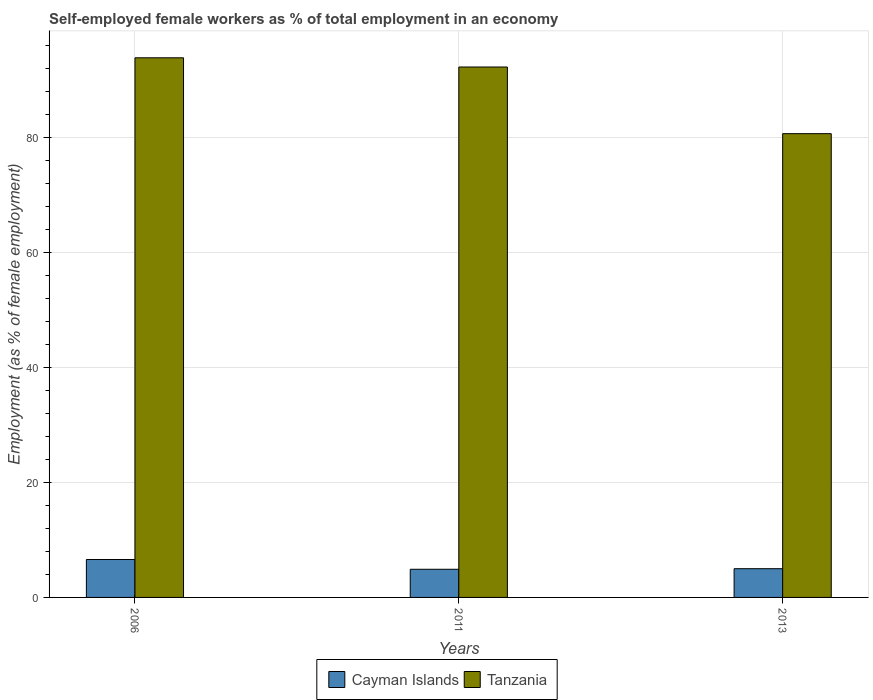How many groups of bars are there?
Offer a very short reply. 3. Are the number of bars per tick equal to the number of legend labels?
Your answer should be compact. Yes. Are the number of bars on each tick of the X-axis equal?
Your answer should be compact. Yes. How many bars are there on the 2nd tick from the right?
Keep it short and to the point. 2. What is the percentage of self-employed female workers in Tanzania in 2011?
Offer a terse response. 92.3. Across all years, what is the maximum percentage of self-employed female workers in Tanzania?
Your answer should be very brief. 93.9. Across all years, what is the minimum percentage of self-employed female workers in Tanzania?
Your answer should be very brief. 80.7. What is the total percentage of self-employed female workers in Cayman Islands in the graph?
Your response must be concise. 16.5. What is the difference between the percentage of self-employed female workers in Tanzania in 2006 and that in 2011?
Your response must be concise. 1.6. What is the difference between the percentage of self-employed female workers in Cayman Islands in 2006 and the percentage of self-employed female workers in Tanzania in 2013?
Provide a short and direct response. -74.1. In the year 2011, what is the difference between the percentage of self-employed female workers in Cayman Islands and percentage of self-employed female workers in Tanzania?
Make the answer very short. -87.4. What is the ratio of the percentage of self-employed female workers in Tanzania in 2006 to that in 2011?
Offer a terse response. 1.02. What is the difference between the highest and the second highest percentage of self-employed female workers in Tanzania?
Give a very brief answer. 1.6. What is the difference between the highest and the lowest percentage of self-employed female workers in Tanzania?
Keep it short and to the point. 13.2. Is the sum of the percentage of self-employed female workers in Tanzania in 2006 and 2011 greater than the maximum percentage of self-employed female workers in Cayman Islands across all years?
Your answer should be compact. Yes. What does the 1st bar from the left in 2013 represents?
Offer a very short reply. Cayman Islands. What does the 2nd bar from the right in 2011 represents?
Offer a terse response. Cayman Islands. How many bars are there?
Your answer should be very brief. 6. Are all the bars in the graph horizontal?
Offer a very short reply. No. How many years are there in the graph?
Make the answer very short. 3. What is the difference between two consecutive major ticks on the Y-axis?
Offer a terse response. 20. Are the values on the major ticks of Y-axis written in scientific E-notation?
Give a very brief answer. No. Does the graph contain any zero values?
Offer a very short reply. No. Does the graph contain grids?
Ensure brevity in your answer.  Yes. Where does the legend appear in the graph?
Your answer should be compact. Bottom center. How many legend labels are there?
Give a very brief answer. 2. How are the legend labels stacked?
Your response must be concise. Horizontal. What is the title of the graph?
Give a very brief answer. Self-employed female workers as % of total employment in an economy. What is the label or title of the Y-axis?
Give a very brief answer. Employment (as % of female employment). What is the Employment (as % of female employment) of Cayman Islands in 2006?
Your answer should be compact. 6.6. What is the Employment (as % of female employment) in Tanzania in 2006?
Make the answer very short. 93.9. What is the Employment (as % of female employment) in Cayman Islands in 2011?
Give a very brief answer. 4.9. What is the Employment (as % of female employment) of Tanzania in 2011?
Your answer should be very brief. 92.3. What is the Employment (as % of female employment) of Tanzania in 2013?
Offer a terse response. 80.7. Across all years, what is the maximum Employment (as % of female employment) in Cayman Islands?
Make the answer very short. 6.6. Across all years, what is the maximum Employment (as % of female employment) of Tanzania?
Give a very brief answer. 93.9. Across all years, what is the minimum Employment (as % of female employment) in Cayman Islands?
Give a very brief answer. 4.9. Across all years, what is the minimum Employment (as % of female employment) in Tanzania?
Your answer should be compact. 80.7. What is the total Employment (as % of female employment) of Tanzania in the graph?
Ensure brevity in your answer.  266.9. What is the difference between the Employment (as % of female employment) in Cayman Islands in 2006 and that in 2011?
Your answer should be compact. 1.7. What is the difference between the Employment (as % of female employment) in Tanzania in 2006 and that in 2011?
Provide a short and direct response. 1.6. What is the difference between the Employment (as % of female employment) in Cayman Islands in 2006 and that in 2013?
Provide a succinct answer. 1.6. What is the difference between the Employment (as % of female employment) of Tanzania in 2006 and that in 2013?
Your answer should be very brief. 13.2. What is the difference between the Employment (as % of female employment) of Cayman Islands in 2011 and that in 2013?
Provide a succinct answer. -0.1. What is the difference between the Employment (as % of female employment) of Tanzania in 2011 and that in 2013?
Your answer should be very brief. 11.6. What is the difference between the Employment (as % of female employment) in Cayman Islands in 2006 and the Employment (as % of female employment) in Tanzania in 2011?
Offer a terse response. -85.7. What is the difference between the Employment (as % of female employment) of Cayman Islands in 2006 and the Employment (as % of female employment) of Tanzania in 2013?
Make the answer very short. -74.1. What is the difference between the Employment (as % of female employment) of Cayman Islands in 2011 and the Employment (as % of female employment) of Tanzania in 2013?
Provide a succinct answer. -75.8. What is the average Employment (as % of female employment) of Cayman Islands per year?
Ensure brevity in your answer.  5.5. What is the average Employment (as % of female employment) in Tanzania per year?
Provide a succinct answer. 88.97. In the year 2006, what is the difference between the Employment (as % of female employment) in Cayman Islands and Employment (as % of female employment) in Tanzania?
Your answer should be very brief. -87.3. In the year 2011, what is the difference between the Employment (as % of female employment) of Cayman Islands and Employment (as % of female employment) of Tanzania?
Your response must be concise. -87.4. In the year 2013, what is the difference between the Employment (as % of female employment) in Cayman Islands and Employment (as % of female employment) in Tanzania?
Keep it short and to the point. -75.7. What is the ratio of the Employment (as % of female employment) in Cayman Islands in 2006 to that in 2011?
Your answer should be very brief. 1.35. What is the ratio of the Employment (as % of female employment) of Tanzania in 2006 to that in 2011?
Your response must be concise. 1.02. What is the ratio of the Employment (as % of female employment) in Cayman Islands in 2006 to that in 2013?
Offer a terse response. 1.32. What is the ratio of the Employment (as % of female employment) of Tanzania in 2006 to that in 2013?
Your response must be concise. 1.16. What is the ratio of the Employment (as % of female employment) in Cayman Islands in 2011 to that in 2013?
Offer a very short reply. 0.98. What is the ratio of the Employment (as % of female employment) of Tanzania in 2011 to that in 2013?
Offer a terse response. 1.14. What is the difference between the highest and the second highest Employment (as % of female employment) of Tanzania?
Give a very brief answer. 1.6. What is the difference between the highest and the lowest Employment (as % of female employment) in Tanzania?
Offer a terse response. 13.2. 